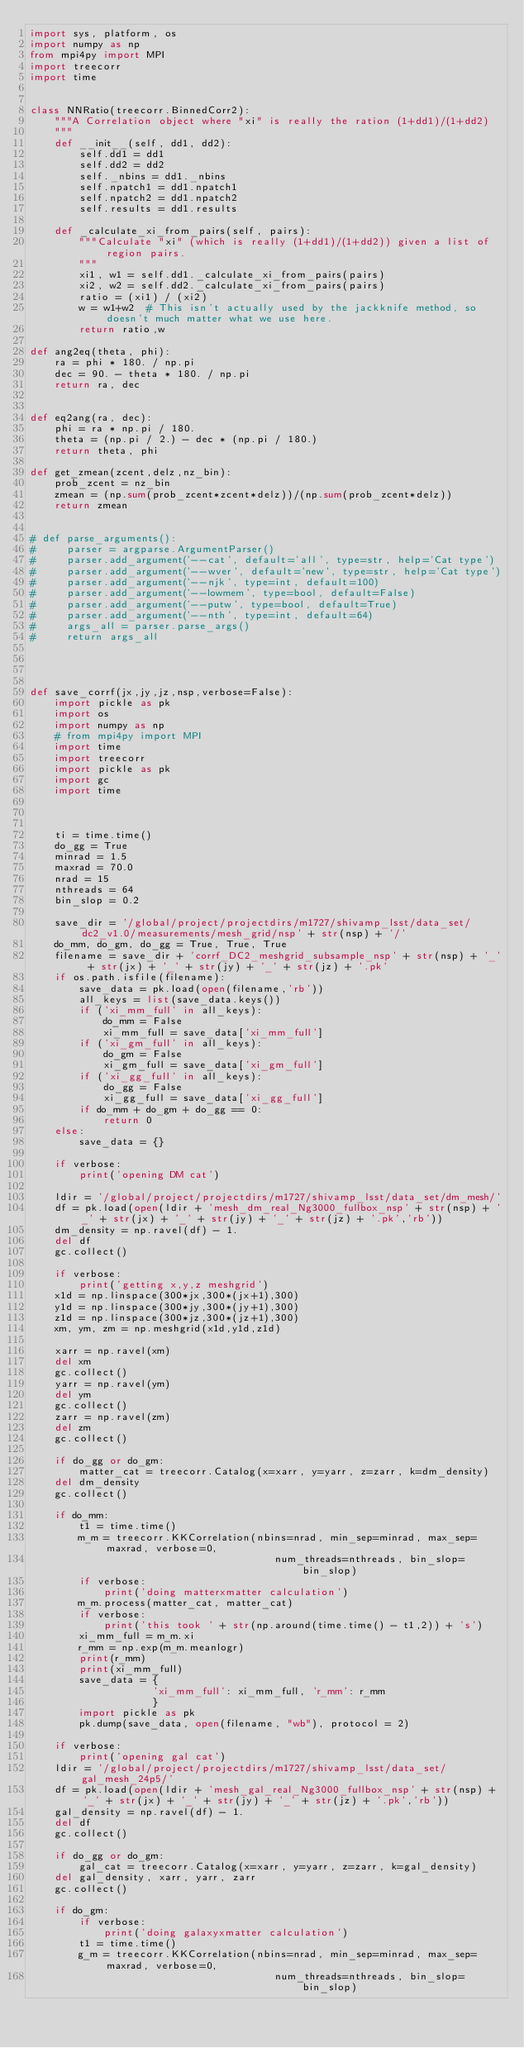Convert code to text. <code><loc_0><loc_0><loc_500><loc_500><_Python_>import sys, platform, os
import numpy as np
from mpi4py import MPI
import treecorr
import time


class NNRatio(treecorr.BinnedCorr2):
    """A Correlation object where "xi" is really the ration (1+dd1)/(1+dd2)
    """
    def __init__(self, dd1, dd2):
        self.dd1 = dd1
        self.dd2 = dd2
        self._nbins = dd1._nbins
        self.npatch1 = dd1.npatch1
        self.npatch2 = dd1.npatch2
        self.results = dd1.results 

    def _calculate_xi_from_pairs(self, pairs):
        """Calculate "xi" (which is really (1+dd1)/(1+dd2)) given a list of region pairs.
        """
        xi1, w1 = self.dd1._calculate_xi_from_pairs(pairs)
        xi2, w2 = self.dd2._calculate_xi_from_pairs(pairs)
        ratio = (xi1) / (xi2)
        w = w1+w2  # This isn't actually used by the jackknife method, so doesn't much matter what we use here.
        return ratio,w

def ang2eq(theta, phi):
    ra = phi * 180. / np.pi
    dec = 90. - theta * 180. / np.pi
    return ra, dec


def eq2ang(ra, dec):
    phi = ra * np.pi / 180.
    theta = (np.pi / 2.) - dec * (np.pi / 180.)
    return theta, phi

def get_zmean(zcent,delz,nz_bin):
    prob_zcent = nz_bin
    zmean = (np.sum(prob_zcent*zcent*delz))/(np.sum(prob_zcent*delz))
    return zmean


# def parse_arguments():
#     parser = argparse.ArgumentParser()
#     parser.add_argument('--cat', default='all', type=str, help='Cat type')
#     parser.add_argument('--wver', default='new', type=str, help='Cat type')
#     parser.add_argument('--njk', type=int, default=100)
#     parser.add_argument('--lowmem', type=bool, default=False)
#     parser.add_argument('--putw', type=bool, default=True)
#     parser.add_argument('--nth', type=int, default=64)
#     args_all = parser.parse_args()
#     return args_all




def save_corrf(jx,jy,jz,nsp,verbose=False):
    import pickle as pk
    import os
    import numpy as np
    # from mpi4py import MPI
    import time
    import treecorr
    import pickle as pk
    import gc
    import time    



    ti = time.time()
    do_gg = True
    minrad = 1.5
    maxrad = 70.0
    nrad = 15
    nthreads = 64
    bin_slop = 0.2

    save_dir = '/global/project/projectdirs/m1727/shivamp_lsst/data_set/dc2_v1.0/measurements/mesh_grid/nsp' + str(nsp) + '/'
    do_mm, do_gm, do_gg = True, True, True
    filename = save_dir + 'corrf_DC2_meshgrid_subsample_nsp' + str(nsp) + '_' + str(jx) + '_' + str(jy) + '_' + str(jz) + '.pk'
    if os.path.isfile(filename):
        save_data = pk.load(open(filename,'rb'))
        all_keys = list(save_data.keys())
        if ('xi_mm_full' in all_keys):
            do_mm = False
            xi_mm_full = save_data['xi_mm_full']
        if ('xi_gm_full' in all_keys):
            do_gm = False
            xi_gm_full = save_data['xi_gm_full']            
        if ('xi_gg_full' in all_keys):
            do_gg = False
            xi_gg_full = save_data['xi_gg_full']            
        if do_mm + do_gm + do_gg == 0:
            return 0
    else:
        save_data = {}

    if verbose:
        print('opening DM cat')

    ldir = '/global/project/projectdirs/m1727/shivamp_lsst/data_set/dm_mesh/'
    df = pk.load(open(ldir + 'mesh_dm_real_Ng3000_fullbox_nsp' + str(nsp) + '_' + str(jx) + '_' + str(jy) + '_' + str(jz) + '.pk','rb'))
    dm_density = np.ravel(df) - 1.
    del df
    gc.collect()

    if verbose:
        print('getting x,y,z meshgrid')
    x1d = np.linspace(300*jx,300*(jx+1),300)
    y1d = np.linspace(300*jy,300*(jy+1),300)
    z1d = np.linspace(300*jz,300*(jz+1),300)
    xm, ym, zm = np.meshgrid(x1d,y1d,z1d)

    xarr = np.ravel(xm)
    del xm
    gc.collect()
    yarr = np.ravel(ym)
    del ym
    gc.collect()
    zarr = np.ravel(zm)
    del zm
    gc.collect()

    if do_gg or do_gm:
        matter_cat = treecorr.Catalog(x=xarr, y=yarr, z=zarr, k=dm_density)               
    del dm_density
    gc.collect()
    
    if do_mm:
        t1 = time.time()
        m_m = treecorr.KKCorrelation(nbins=nrad, min_sep=minrad, max_sep=maxrad, verbose=0,
                                        num_threads=nthreads, bin_slop=bin_slop)
        if verbose:
            print('doing matterxmatter calculation')
        m_m.process(matter_cat, matter_cat)
        if verbose:
            print('this took ' + str(np.around(time.time() - t1,2)) + 's')
        xi_mm_full = m_m.xi
        r_mm = np.exp(m_m.meanlogr)
        print(r_mm)
        print(xi_mm_full)
        save_data = {
                    'xi_mm_full': xi_mm_full, 'r_mm': r_mm
                    }
        import pickle as pk
        pk.dump(save_data, open(filename, "wb"), protocol = 2)

    if verbose:
        print('opening gal cat')
    ldir = '/global/project/projectdirs/m1727/shivamp_lsst/data_set/gal_mesh_24p5/'
    df = pk.load(open(ldir + 'mesh_gal_real_Ng3000_fullbox_nsp' + str(nsp) + '_' + str(jx) + '_' + str(jy) + '_' + str(jz) + '.pk','rb'))
    gal_density = np.ravel(df) - 1.
    del df
    gc.collect()

    if do_gg or do_gm:
        gal_cat = treecorr.Catalog(x=xarr, y=yarr, z=zarr, k=gal_density)
    del gal_density, xarr, yarr, zarr
    gc.collect()

    if do_gm:
        if verbose:
            print('doing galaxyxmatter calculation')
        t1 = time.time()
        g_m = treecorr.KKCorrelation(nbins=nrad, min_sep=minrad, max_sep=maxrad, verbose=0,
                                        num_threads=nthreads, bin_slop=bin_slop) </code> 